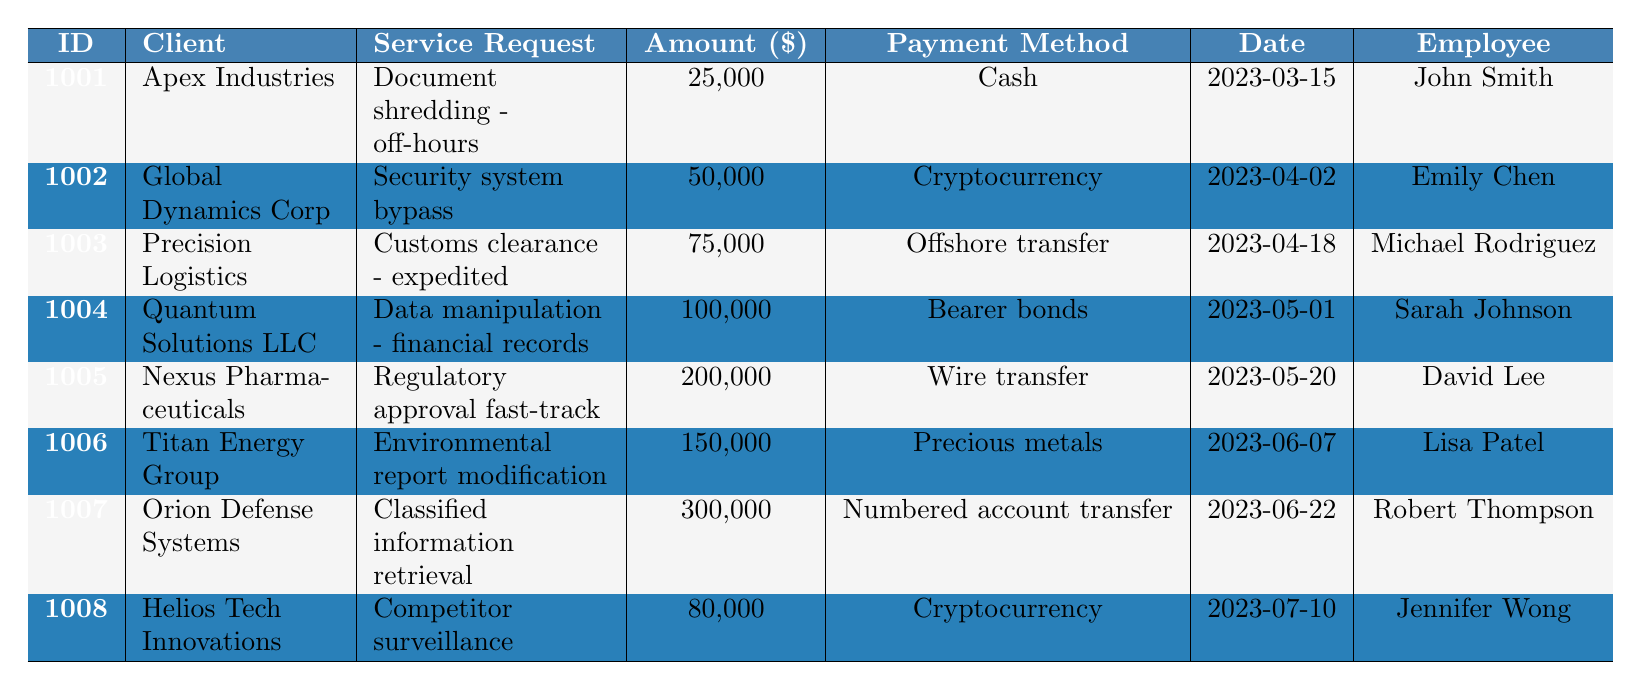What is the payment method used by Apex Industries? The table shows the payment method for Apex Industries, which is found in the "Payment Method" column corresponding to client_id 1001. It states "Cash."
Answer: Cash Which client made the highest payment and what was the amount? By checking the "Amount" column, we find that Orion Defense Systems made the highest payment of $300,000 corresponding to client_id 1007.
Answer: $300,000 How many clients requested services involving "Cryptocurrency"? From the table, we see that there are two clients, Global Dynamics Corp and Helios Tech Innovations, both of which have "Cryptocurrency" listed in the "Payment Method" column.
Answer: 2 What is the total amount paid for all service requests? To find the total, we sum all the amounts: 25,000 + 50,000 + 75,000 + 100,000 + 200,000 + 150,000 + 300,000 + 80,000 = 980,000.
Answer: $980,000 Did any client request a service related to "Data manipulation"? By looking in the "Service Request" column, we find that Quantum Solutions LLC requested "Data manipulation - financial records," confirming the request exists.
Answer: Yes Which payment method was used by the client that requested "Regulatory approval fast-track"? The "Payment Method" column for Nexus Pharmaceuticals (client_id 1005) shows that the payment method used was "Wire transfer."
Answer: Wire transfer How many clients requested services with payment amounts greater than $100,000? By analyzing the "Amount" column, we see that four clients (Nexus Pharmaceuticals, Titan Energy Group, Orion Defense Systems) have amounts greater than $100,000, which are $200,000, $150,000, and $300,000, respectively.
Answer: 3 What is the average payment amount across all clients? First, we calculate the total payments, which is $980,000, then divide this by the number of clients, which is 8. Therefore, the average payment is 980,000 / 8 = 122,500.
Answer: $122,500 Which employee was assigned to the service request involving "Classified information retrieval"? By noting the "Employee" column, we find that Robert Thompson was assigned to the request for Orion Defense Systems (client_id 1007).
Answer: Robert Thompson Is there a client that has made a payment using bearer bonds? The entry for Quantum Solutions LLC indicates a payment method of "Bearer bonds," confirming the existence of such a transaction.
Answer: Yes 